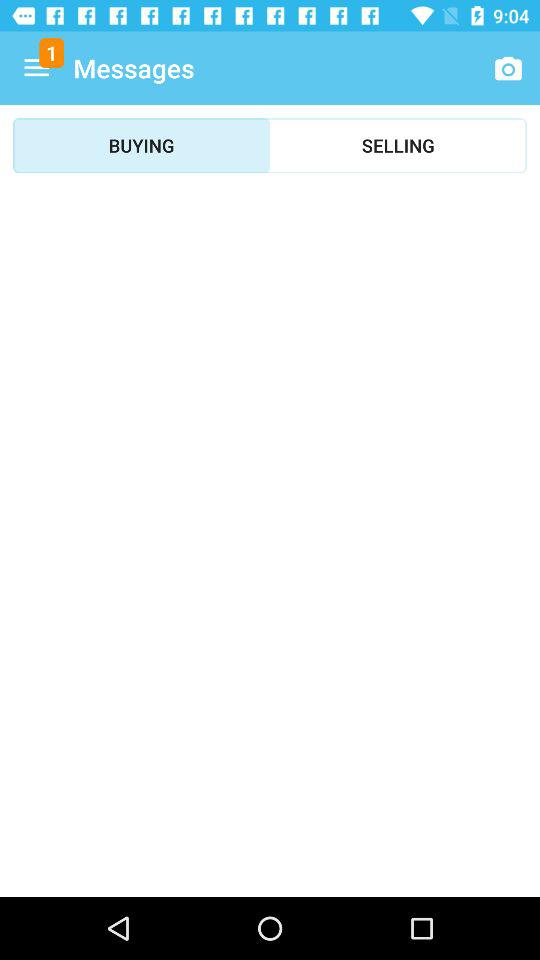How many notifications are there in "SELLING"?
When the provided information is insufficient, respond with <no answer>. <no answer> 